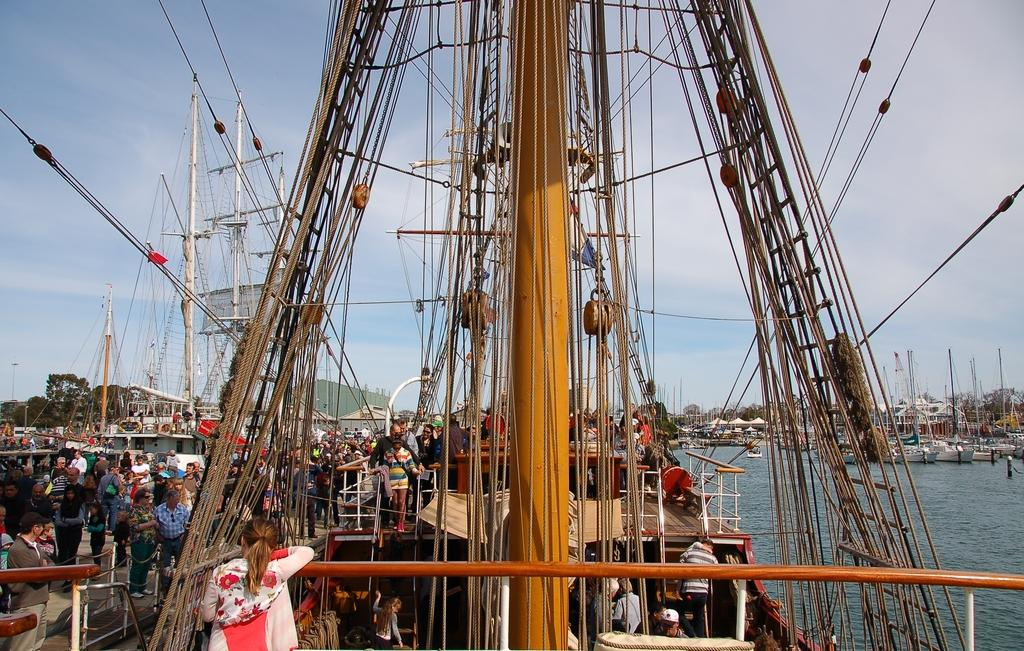What type of vehicles can be seen in the image? There are ships in the image. Who is present in the ships? There are people in the ships. What type of natural environment can be seen in the image? Trees are visible in the image. What man-made structures can be seen in the image? Wires and poles are visible in the image. Can you describe the people visible in the image? There are people visible in the image. What natural element is visible in the image? There is water visible in the image. What part of the sky is visible in the image? The sky is visible in the image. Where are the ships located in the image? The ships are on the water surface. What is the chance of winning a lottery in the image? There is no mention of a lottery or any chance of winning in the image. How does the person in the image cough? There is no person coughing in the image. 